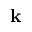<formula> <loc_0><loc_0><loc_500><loc_500>k</formula> 